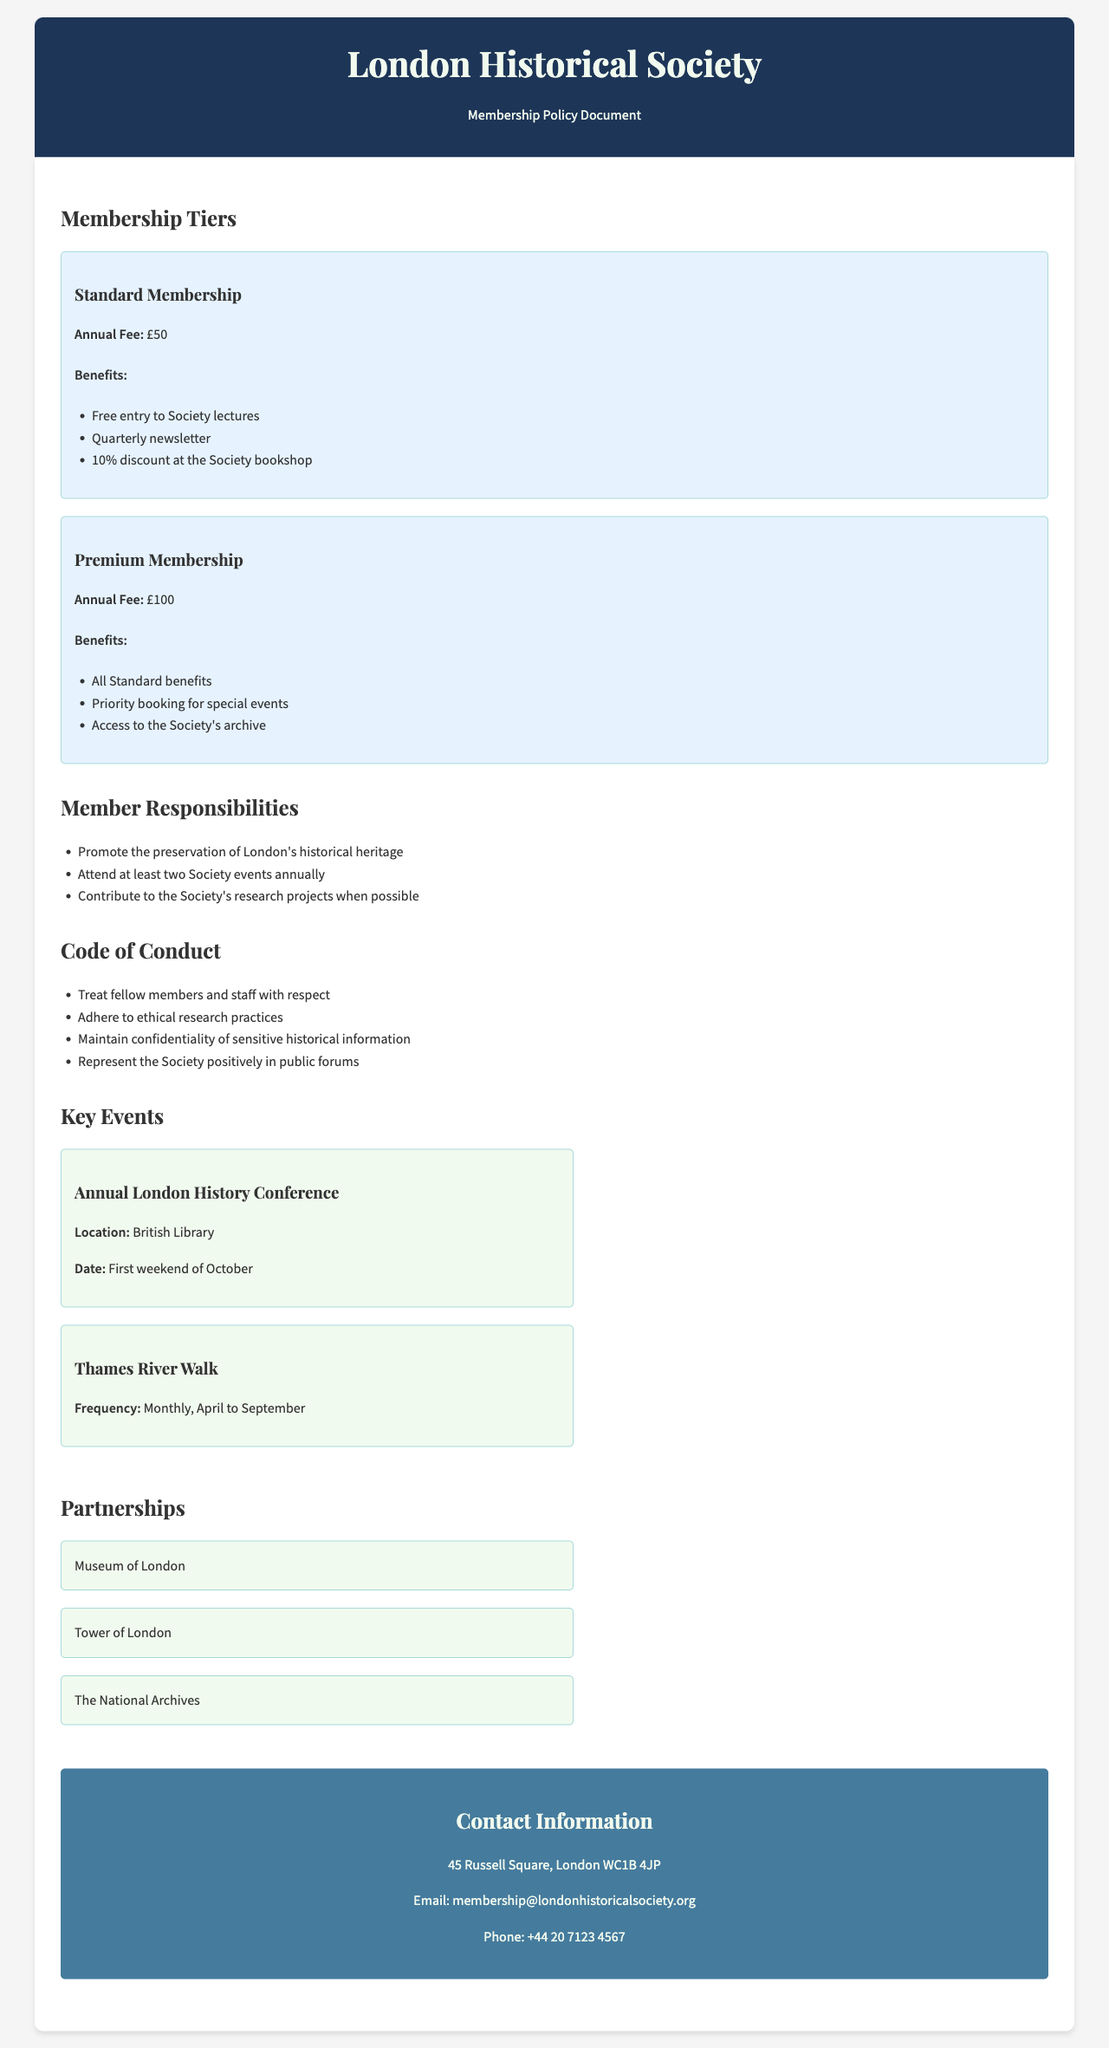What is the annual fee for Standard Membership? The document states the annual fee for Standard Membership is £50.
Answer: £50 What benefits does Premium Membership include? The document lists the benefits of Premium Membership, which include all Standard benefits, priority booking, and access to the Society's archive.
Answer: All Standard benefits, priority booking for special events, access to the Society's archive How many Society events must a member attend each year? The document specifies that members are expected to attend at least two Society events annually.
Answer: Two What is the location of the Annual London History Conference? The document lists the British Library as the location for the Annual London History Conference.
Answer: British Library Which three institutions are mentioned as partnerships? The document lists the Museum of London, Tower of London, and The National Archives as partners.
Answer: Museum of London, Tower of London, The National Archives What is one responsibility of members? The document states one of the member responsibilities is to promote the preservation of London's historical heritage.
Answer: Promote the preservation of London's historical heritage What is the frequency of the Thames River Walk? The document indicates the Thames River Walk occurs monthly from April to September.
Answer: Monthly, April to September How should members treat fellow members and staff? The document emphasizes that members should treat fellow members and staff with respect.
Answer: With respect 